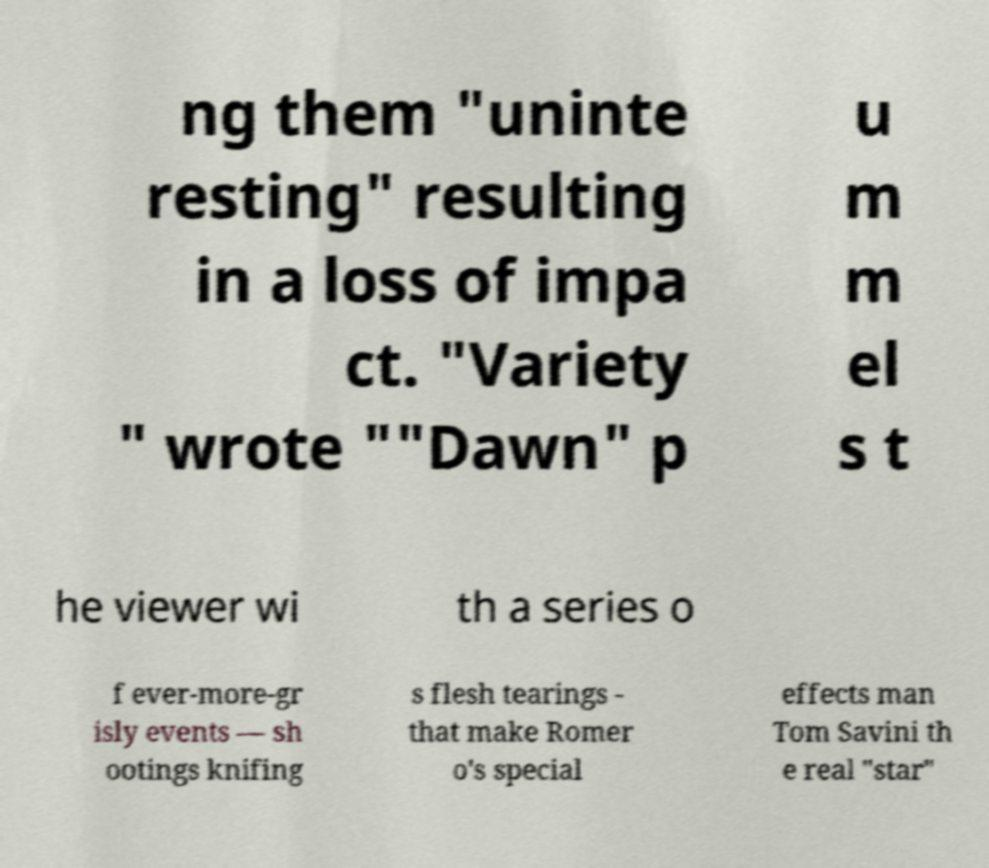What messages or text are displayed in this image? I need them in a readable, typed format. ng them "uninte resting" resulting in a loss of impa ct. "Variety " wrote ""Dawn" p u m m el s t he viewer wi th a series o f ever-more-gr isly events — sh ootings knifing s flesh tearings - that make Romer o's special effects man Tom Savini th e real "star" 